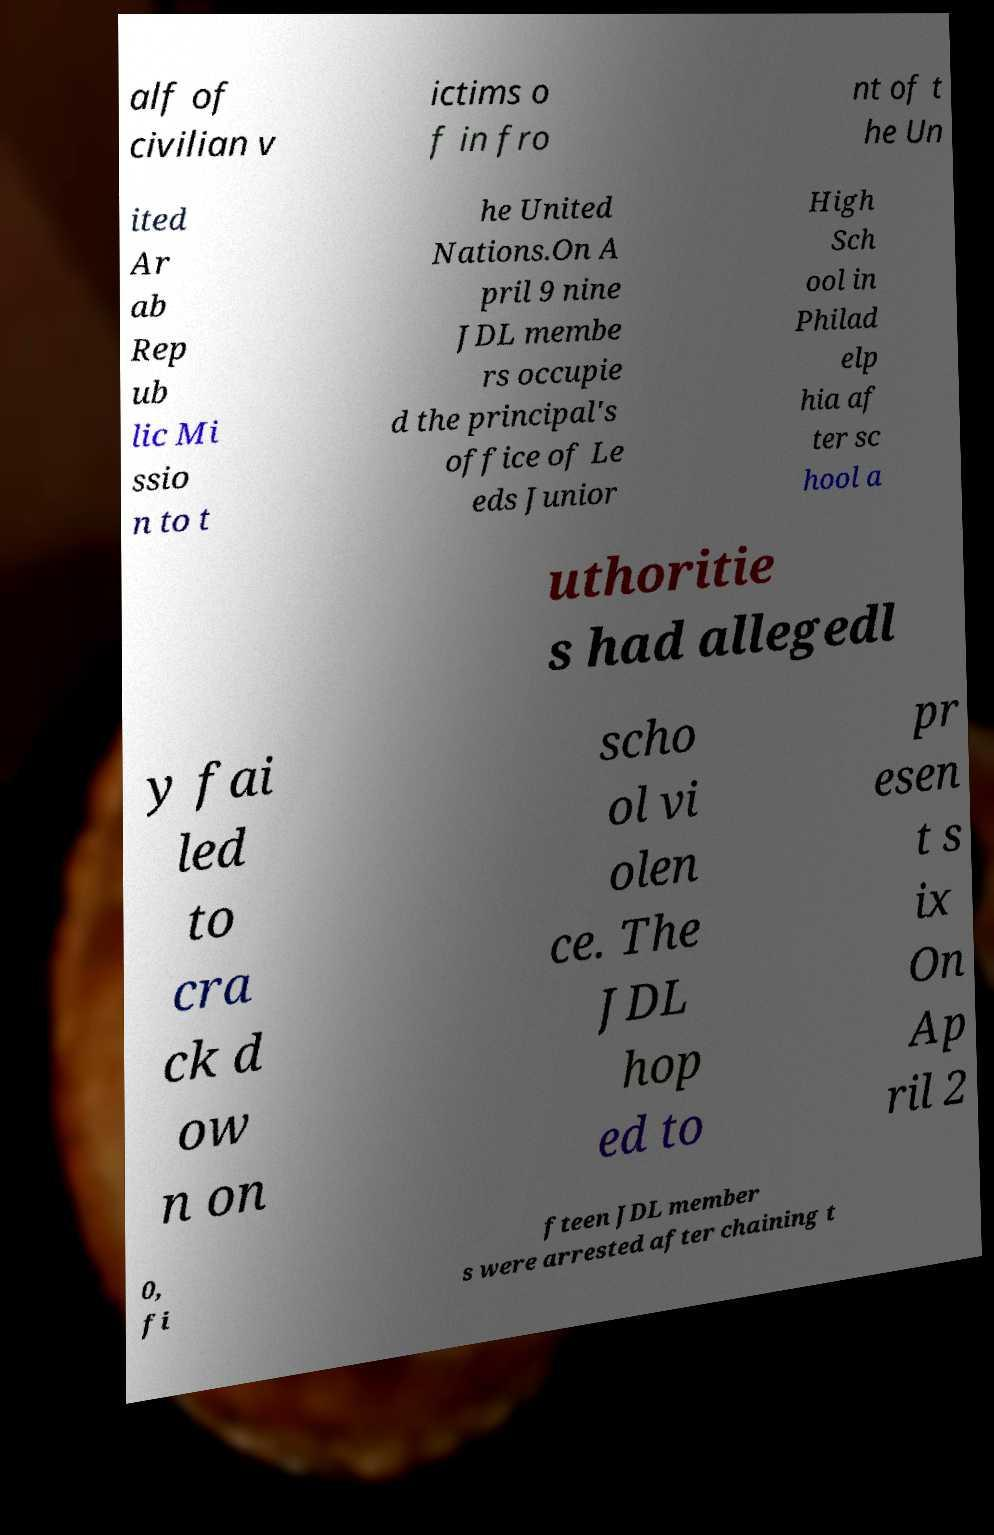Please read and relay the text visible in this image. What does it say? alf of civilian v ictims o f in fro nt of t he Un ited Ar ab Rep ub lic Mi ssio n to t he United Nations.On A pril 9 nine JDL membe rs occupie d the principal's office of Le eds Junior High Sch ool in Philad elp hia af ter sc hool a uthoritie s had allegedl y fai led to cra ck d ow n on scho ol vi olen ce. The JDL hop ed to pr esen t s ix On Ap ril 2 0, fi fteen JDL member s were arrested after chaining t 